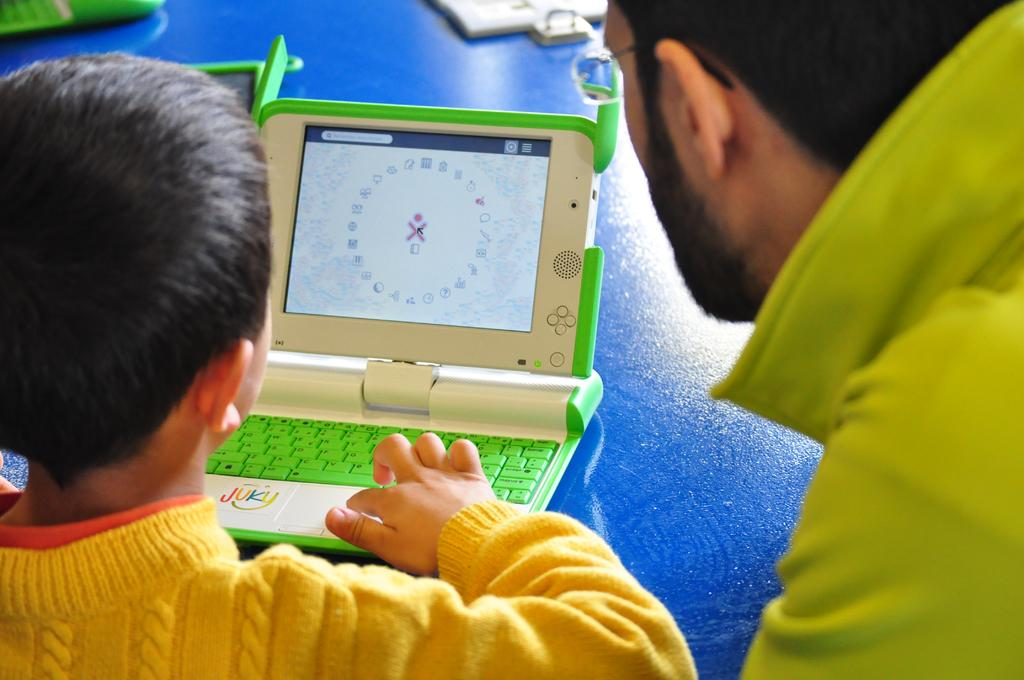How many people are in the image? There are two persons in the image. What is the person wearing a yellow shirt doing? The person in the yellow shirt is playing with a toy laptop. What color is the background of the image? The background of the image is blue. What type of mark can be seen on the toy laptop in the image? There is no mark visible on the toy laptop in the image. What does the voice of the person in the yellow shirt sound like? The image does not provide any information about the person's voice, so it cannot be determined. 